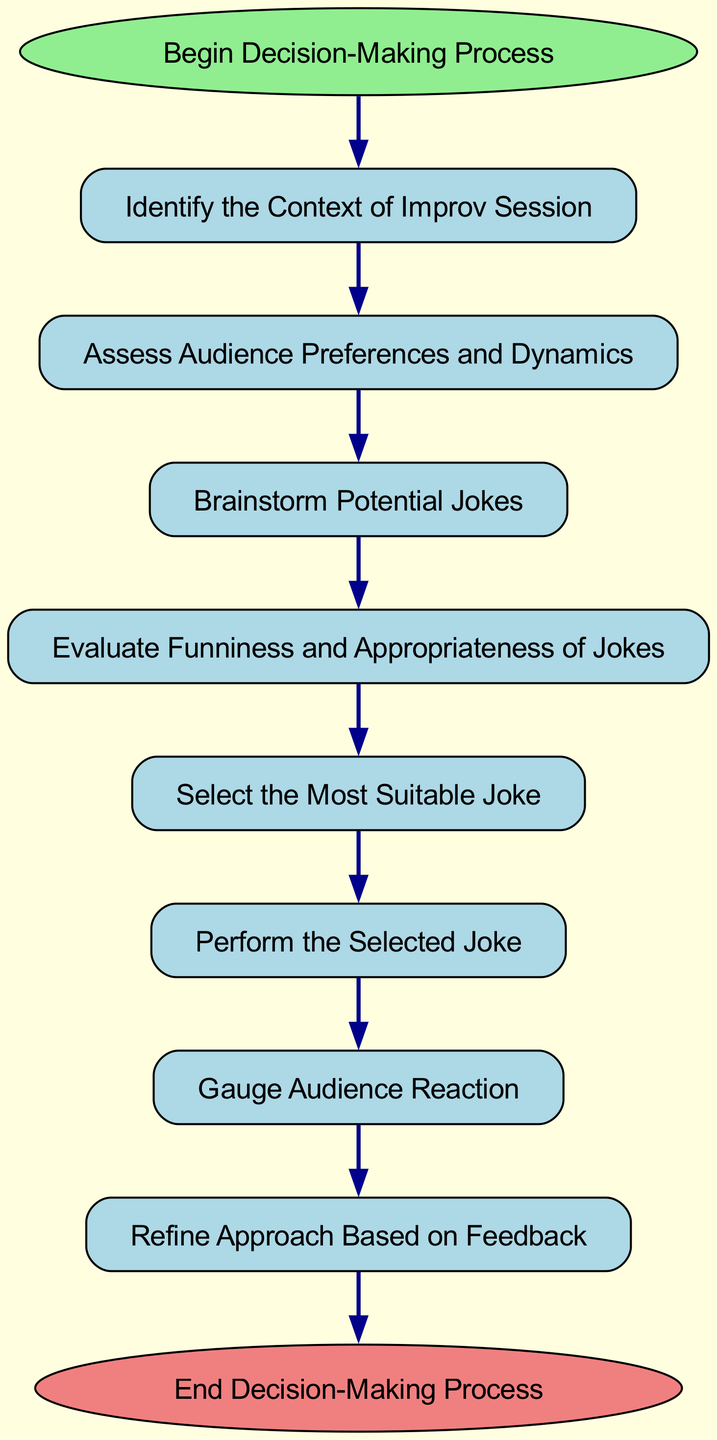What is the first step in the decision-making process? The flow chart starts with the node labeled "Begin Decision-Making Process," indicating that this is the first step before any other action is taken.
Answer: Begin Decision-Making Process How many nodes are there in the flow chart? The flow chart contains ten nodes, with one representing the start, one for the end, and the others detailing various steps in the decision-making process.
Answer: Ten What follows after "Brainstorm Potential Jokes"? According to the flow chart, the step that follows "Brainstorm Potential Jokes" is "Evaluate Funniness and Appropriateness of Jokes."
Answer: Evaluate Funniness and Appropriateness of Jokes Which node leads to "Refine Approach Based on Feedback"? The node that leads to "Refine Approach Based on Feedback" is "Gauge Audience Reaction," indicating that feedback from the audience influences the approach to jokes.
Answer: Gauge Audience Reaction What is the relationship between "Select the Most Suitable Joke" and "Perform the Selected Joke"? The diagram shows a direct connection from "Select the Most Suitable Joke" to "Perform the Selected Joke," indicating that once a joke is selected, it is immediately performed.
Answer: Direct connection After performing the joke, what is the next action? Following the action of "Perform the Selected Joke," the next action in the flow chart is to "Gauge Audience Reaction." This indicates that feedback is collected after the joke performance.
Answer: Gauge Audience Reaction How many connections are present in the flow chart? The flow chart includes nine connections that link each step of the decision-making process in sequence from start to end.
Answer: Nine What is the significance of the "End Decision-Making Process" node? The "End Decision-Making Process" node signifies the conclusion of the entire decision-making process after refining the approach based on audience feedback.
Answer: Conclusion of process 